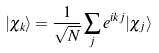<formula> <loc_0><loc_0><loc_500><loc_500>| \chi _ { k } \rangle = \frac { 1 } { \sqrt { N } } \sum _ { j } e ^ { i k j } | \chi _ { j } \rangle</formula> 